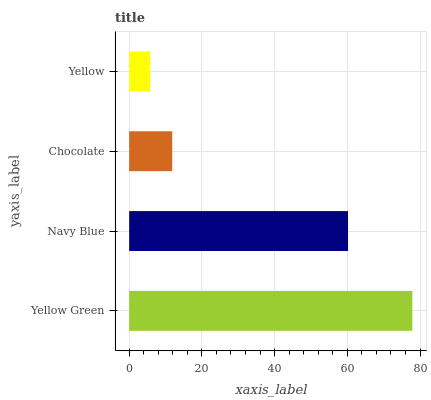Is Yellow the minimum?
Answer yes or no. Yes. Is Yellow Green the maximum?
Answer yes or no. Yes. Is Navy Blue the minimum?
Answer yes or no. No. Is Navy Blue the maximum?
Answer yes or no. No. Is Yellow Green greater than Navy Blue?
Answer yes or no. Yes. Is Navy Blue less than Yellow Green?
Answer yes or no. Yes. Is Navy Blue greater than Yellow Green?
Answer yes or no. No. Is Yellow Green less than Navy Blue?
Answer yes or no. No. Is Navy Blue the high median?
Answer yes or no. Yes. Is Chocolate the low median?
Answer yes or no. Yes. Is Yellow Green the high median?
Answer yes or no. No. Is Navy Blue the low median?
Answer yes or no. No. 